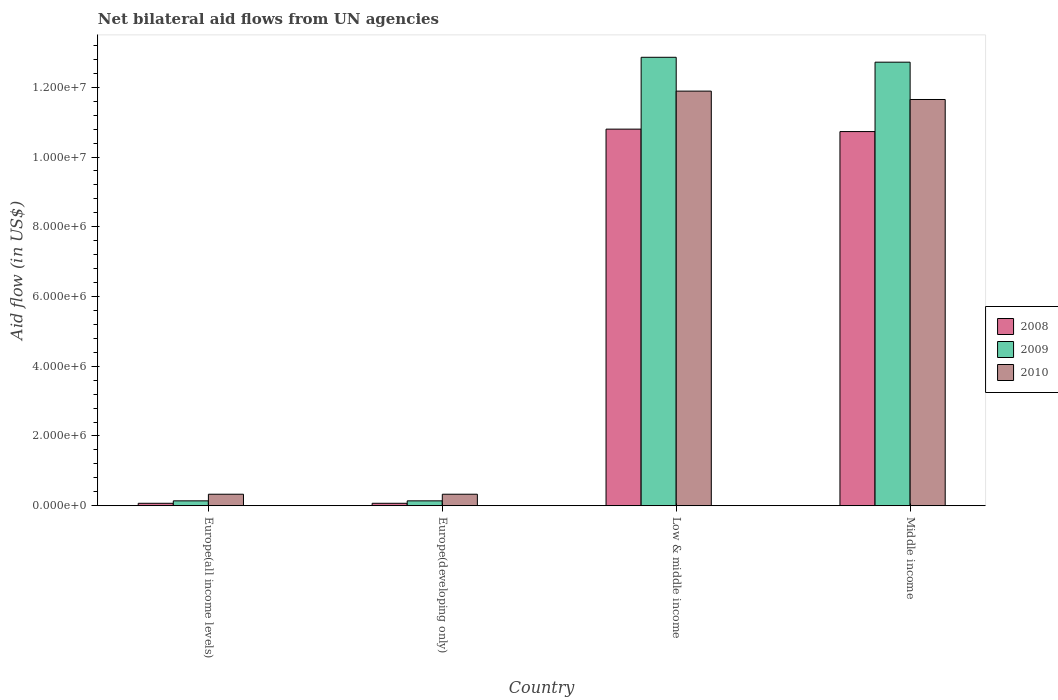How many different coloured bars are there?
Offer a very short reply. 3. How many groups of bars are there?
Ensure brevity in your answer.  4. Are the number of bars on each tick of the X-axis equal?
Ensure brevity in your answer.  Yes. How many bars are there on the 3rd tick from the left?
Offer a very short reply. 3. How many bars are there on the 3rd tick from the right?
Provide a short and direct response. 3. What is the label of the 1st group of bars from the left?
Offer a terse response. Europe(all income levels). In how many cases, is the number of bars for a given country not equal to the number of legend labels?
Your response must be concise. 0. What is the net bilateral aid flow in 2010 in Middle income?
Give a very brief answer. 1.16e+07. Across all countries, what is the maximum net bilateral aid flow in 2008?
Provide a short and direct response. 1.08e+07. In which country was the net bilateral aid flow in 2010 minimum?
Make the answer very short. Europe(all income levels). What is the total net bilateral aid flow in 2009 in the graph?
Keep it short and to the point. 2.59e+07. What is the difference between the net bilateral aid flow in 2009 in Europe(all income levels) and that in Middle income?
Your response must be concise. -1.26e+07. What is the difference between the net bilateral aid flow in 2010 in Europe(all income levels) and the net bilateral aid flow in 2008 in Middle income?
Your answer should be compact. -1.04e+07. What is the average net bilateral aid flow in 2008 per country?
Make the answer very short. 5.42e+06. What is the ratio of the net bilateral aid flow in 2010 in Europe(developing only) to that in Low & middle income?
Provide a short and direct response. 0.03. Is the difference between the net bilateral aid flow in 2009 in Europe(all income levels) and Low & middle income greater than the difference between the net bilateral aid flow in 2010 in Europe(all income levels) and Low & middle income?
Offer a terse response. No. What is the difference between the highest and the second highest net bilateral aid flow in 2010?
Provide a short and direct response. 1.16e+07. What is the difference between the highest and the lowest net bilateral aid flow in 2009?
Provide a succinct answer. 1.27e+07. In how many countries, is the net bilateral aid flow in 2008 greater than the average net bilateral aid flow in 2008 taken over all countries?
Provide a short and direct response. 2. What does the 1st bar from the left in Low & middle income represents?
Provide a succinct answer. 2008. Are the values on the major ticks of Y-axis written in scientific E-notation?
Offer a very short reply. Yes. Does the graph contain any zero values?
Your response must be concise. No. Does the graph contain grids?
Provide a succinct answer. No. What is the title of the graph?
Provide a succinct answer. Net bilateral aid flows from UN agencies. What is the label or title of the X-axis?
Give a very brief answer. Country. What is the label or title of the Y-axis?
Give a very brief answer. Aid flow (in US$). What is the Aid flow (in US$) in 2008 in Europe(all income levels)?
Offer a terse response. 7.00e+04. What is the Aid flow (in US$) of 2009 in Europe(all income levels)?
Your answer should be compact. 1.40e+05. What is the Aid flow (in US$) of 2010 in Europe(all income levels)?
Make the answer very short. 3.30e+05. What is the Aid flow (in US$) of 2009 in Europe(developing only)?
Ensure brevity in your answer.  1.40e+05. What is the Aid flow (in US$) in 2010 in Europe(developing only)?
Your response must be concise. 3.30e+05. What is the Aid flow (in US$) of 2008 in Low & middle income?
Your answer should be very brief. 1.08e+07. What is the Aid flow (in US$) in 2009 in Low & middle income?
Provide a short and direct response. 1.29e+07. What is the Aid flow (in US$) of 2010 in Low & middle income?
Keep it short and to the point. 1.19e+07. What is the Aid flow (in US$) of 2008 in Middle income?
Offer a terse response. 1.07e+07. What is the Aid flow (in US$) of 2009 in Middle income?
Give a very brief answer. 1.27e+07. What is the Aid flow (in US$) in 2010 in Middle income?
Make the answer very short. 1.16e+07. Across all countries, what is the maximum Aid flow (in US$) of 2008?
Keep it short and to the point. 1.08e+07. Across all countries, what is the maximum Aid flow (in US$) in 2009?
Make the answer very short. 1.29e+07. Across all countries, what is the maximum Aid flow (in US$) of 2010?
Your answer should be compact. 1.19e+07. Across all countries, what is the minimum Aid flow (in US$) of 2008?
Your answer should be very brief. 7.00e+04. What is the total Aid flow (in US$) in 2008 in the graph?
Your answer should be very brief. 2.17e+07. What is the total Aid flow (in US$) of 2009 in the graph?
Make the answer very short. 2.59e+07. What is the total Aid flow (in US$) in 2010 in the graph?
Keep it short and to the point. 2.42e+07. What is the difference between the Aid flow (in US$) in 2009 in Europe(all income levels) and that in Europe(developing only)?
Keep it short and to the point. 0. What is the difference between the Aid flow (in US$) of 2010 in Europe(all income levels) and that in Europe(developing only)?
Provide a short and direct response. 0. What is the difference between the Aid flow (in US$) in 2008 in Europe(all income levels) and that in Low & middle income?
Give a very brief answer. -1.07e+07. What is the difference between the Aid flow (in US$) in 2009 in Europe(all income levels) and that in Low & middle income?
Offer a very short reply. -1.27e+07. What is the difference between the Aid flow (in US$) in 2010 in Europe(all income levels) and that in Low & middle income?
Ensure brevity in your answer.  -1.16e+07. What is the difference between the Aid flow (in US$) in 2008 in Europe(all income levels) and that in Middle income?
Keep it short and to the point. -1.07e+07. What is the difference between the Aid flow (in US$) in 2009 in Europe(all income levels) and that in Middle income?
Provide a succinct answer. -1.26e+07. What is the difference between the Aid flow (in US$) in 2010 in Europe(all income levels) and that in Middle income?
Provide a succinct answer. -1.13e+07. What is the difference between the Aid flow (in US$) of 2008 in Europe(developing only) and that in Low & middle income?
Offer a terse response. -1.07e+07. What is the difference between the Aid flow (in US$) of 2009 in Europe(developing only) and that in Low & middle income?
Offer a terse response. -1.27e+07. What is the difference between the Aid flow (in US$) in 2010 in Europe(developing only) and that in Low & middle income?
Provide a succinct answer. -1.16e+07. What is the difference between the Aid flow (in US$) of 2008 in Europe(developing only) and that in Middle income?
Provide a short and direct response. -1.07e+07. What is the difference between the Aid flow (in US$) of 2009 in Europe(developing only) and that in Middle income?
Your answer should be compact. -1.26e+07. What is the difference between the Aid flow (in US$) in 2010 in Europe(developing only) and that in Middle income?
Offer a terse response. -1.13e+07. What is the difference between the Aid flow (in US$) in 2008 in Europe(all income levels) and the Aid flow (in US$) in 2009 in Europe(developing only)?
Keep it short and to the point. -7.00e+04. What is the difference between the Aid flow (in US$) of 2009 in Europe(all income levels) and the Aid flow (in US$) of 2010 in Europe(developing only)?
Your answer should be very brief. -1.90e+05. What is the difference between the Aid flow (in US$) of 2008 in Europe(all income levels) and the Aid flow (in US$) of 2009 in Low & middle income?
Give a very brief answer. -1.28e+07. What is the difference between the Aid flow (in US$) of 2008 in Europe(all income levels) and the Aid flow (in US$) of 2010 in Low & middle income?
Offer a terse response. -1.18e+07. What is the difference between the Aid flow (in US$) of 2009 in Europe(all income levels) and the Aid flow (in US$) of 2010 in Low & middle income?
Your answer should be compact. -1.18e+07. What is the difference between the Aid flow (in US$) in 2008 in Europe(all income levels) and the Aid flow (in US$) in 2009 in Middle income?
Your answer should be very brief. -1.26e+07. What is the difference between the Aid flow (in US$) in 2008 in Europe(all income levels) and the Aid flow (in US$) in 2010 in Middle income?
Offer a terse response. -1.16e+07. What is the difference between the Aid flow (in US$) of 2009 in Europe(all income levels) and the Aid flow (in US$) of 2010 in Middle income?
Provide a succinct answer. -1.15e+07. What is the difference between the Aid flow (in US$) in 2008 in Europe(developing only) and the Aid flow (in US$) in 2009 in Low & middle income?
Offer a very short reply. -1.28e+07. What is the difference between the Aid flow (in US$) in 2008 in Europe(developing only) and the Aid flow (in US$) in 2010 in Low & middle income?
Ensure brevity in your answer.  -1.18e+07. What is the difference between the Aid flow (in US$) of 2009 in Europe(developing only) and the Aid flow (in US$) of 2010 in Low & middle income?
Provide a succinct answer. -1.18e+07. What is the difference between the Aid flow (in US$) of 2008 in Europe(developing only) and the Aid flow (in US$) of 2009 in Middle income?
Ensure brevity in your answer.  -1.26e+07. What is the difference between the Aid flow (in US$) in 2008 in Europe(developing only) and the Aid flow (in US$) in 2010 in Middle income?
Your answer should be compact. -1.16e+07. What is the difference between the Aid flow (in US$) in 2009 in Europe(developing only) and the Aid flow (in US$) in 2010 in Middle income?
Provide a short and direct response. -1.15e+07. What is the difference between the Aid flow (in US$) of 2008 in Low & middle income and the Aid flow (in US$) of 2009 in Middle income?
Provide a short and direct response. -1.92e+06. What is the difference between the Aid flow (in US$) of 2008 in Low & middle income and the Aid flow (in US$) of 2010 in Middle income?
Provide a short and direct response. -8.50e+05. What is the difference between the Aid flow (in US$) of 2009 in Low & middle income and the Aid flow (in US$) of 2010 in Middle income?
Provide a short and direct response. 1.21e+06. What is the average Aid flow (in US$) of 2008 per country?
Ensure brevity in your answer.  5.42e+06. What is the average Aid flow (in US$) in 2009 per country?
Provide a succinct answer. 6.46e+06. What is the average Aid flow (in US$) in 2010 per country?
Provide a short and direct response. 6.05e+06. What is the difference between the Aid flow (in US$) of 2008 and Aid flow (in US$) of 2009 in Europe(all income levels)?
Ensure brevity in your answer.  -7.00e+04. What is the difference between the Aid flow (in US$) of 2008 and Aid flow (in US$) of 2010 in Europe(all income levels)?
Keep it short and to the point. -2.60e+05. What is the difference between the Aid flow (in US$) in 2009 and Aid flow (in US$) in 2010 in Europe(all income levels)?
Offer a terse response. -1.90e+05. What is the difference between the Aid flow (in US$) in 2008 and Aid flow (in US$) in 2009 in Europe(developing only)?
Your response must be concise. -7.00e+04. What is the difference between the Aid flow (in US$) of 2008 and Aid flow (in US$) of 2010 in Europe(developing only)?
Your answer should be very brief. -2.60e+05. What is the difference between the Aid flow (in US$) in 2009 and Aid flow (in US$) in 2010 in Europe(developing only)?
Make the answer very short. -1.90e+05. What is the difference between the Aid flow (in US$) in 2008 and Aid flow (in US$) in 2009 in Low & middle income?
Your answer should be compact. -2.06e+06. What is the difference between the Aid flow (in US$) of 2008 and Aid flow (in US$) of 2010 in Low & middle income?
Offer a terse response. -1.09e+06. What is the difference between the Aid flow (in US$) of 2009 and Aid flow (in US$) of 2010 in Low & middle income?
Give a very brief answer. 9.70e+05. What is the difference between the Aid flow (in US$) of 2008 and Aid flow (in US$) of 2009 in Middle income?
Provide a short and direct response. -1.99e+06. What is the difference between the Aid flow (in US$) of 2008 and Aid flow (in US$) of 2010 in Middle income?
Your answer should be very brief. -9.20e+05. What is the difference between the Aid flow (in US$) in 2009 and Aid flow (in US$) in 2010 in Middle income?
Provide a short and direct response. 1.07e+06. What is the ratio of the Aid flow (in US$) in 2009 in Europe(all income levels) to that in Europe(developing only)?
Keep it short and to the point. 1. What is the ratio of the Aid flow (in US$) in 2010 in Europe(all income levels) to that in Europe(developing only)?
Offer a terse response. 1. What is the ratio of the Aid flow (in US$) in 2008 in Europe(all income levels) to that in Low & middle income?
Give a very brief answer. 0.01. What is the ratio of the Aid flow (in US$) of 2009 in Europe(all income levels) to that in Low & middle income?
Keep it short and to the point. 0.01. What is the ratio of the Aid flow (in US$) of 2010 in Europe(all income levels) to that in Low & middle income?
Provide a succinct answer. 0.03. What is the ratio of the Aid flow (in US$) of 2008 in Europe(all income levels) to that in Middle income?
Make the answer very short. 0.01. What is the ratio of the Aid flow (in US$) in 2009 in Europe(all income levels) to that in Middle income?
Make the answer very short. 0.01. What is the ratio of the Aid flow (in US$) in 2010 in Europe(all income levels) to that in Middle income?
Make the answer very short. 0.03. What is the ratio of the Aid flow (in US$) of 2008 in Europe(developing only) to that in Low & middle income?
Provide a short and direct response. 0.01. What is the ratio of the Aid flow (in US$) of 2009 in Europe(developing only) to that in Low & middle income?
Keep it short and to the point. 0.01. What is the ratio of the Aid flow (in US$) of 2010 in Europe(developing only) to that in Low & middle income?
Make the answer very short. 0.03. What is the ratio of the Aid flow (in US$) of 2008 in Europe(developing only) to that in Middle income?
Provide a short and direct response. 0.01. What is the ratio of the Aid flow (in US$) of 2009 in Europe(developing only) to that in Middle income?
Give a very brief answer. 0.01. What is the ratio of the Aid flow (in US$) in 2010 in Europe(developing only) to that in Middle income?
Ensure brevity in your answer.  0.03. What is the ratio of the Aid flow (in US$) in 2008 in Low & middle income to that in Middle income?
Offer a very short reply. 1.01. What is the ratio of the Aid flow (in US$) in 2009 in Low & middle income to that in Middle income?
Your answer should be compact. 1.01. What is the ratio of the Aid flow (in US$) in 2010 in Low & middle income to that in Middle income?
Your response must be concise. 1.02. What is the difference between the highest and the second highest Aid flow (in US$) in 2008?
Offer a very short reply. 7.00e+04. What is the difference between the highest and the second highest Aid flow (in US$) in 2009?
Give a very brief answer. 1.40e+05. What is the difference between the highest and the lowest Aid flow (in US$) of 2008?
Keep it short and to the point. 1.07e+07. What is the difference between the highest and the lowest Aid flow (in US$) in 2009?
Make the answer very short. 1.27e+07. What is the difference between the highest and the lowest Aid flow (in US$) in 2010?
Your answer should be compact. 1.16e+07. 